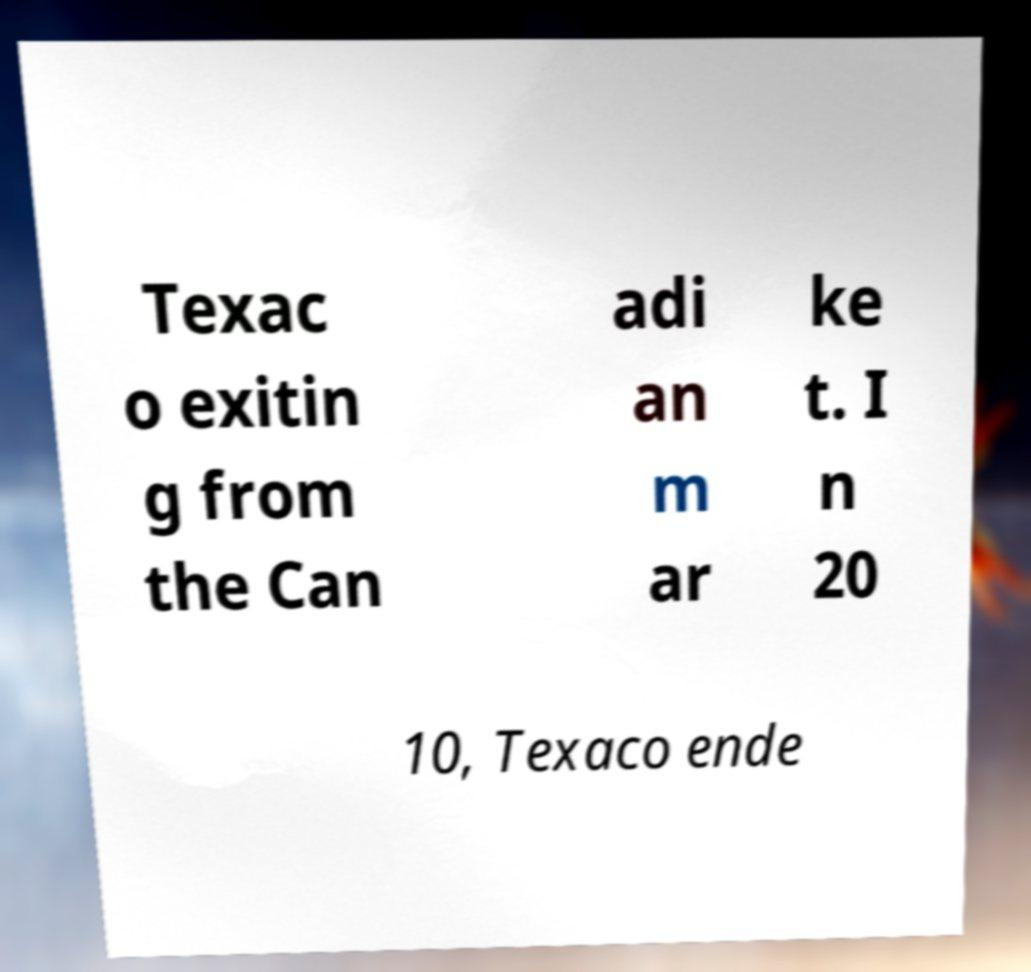Could you assist in decoding the text presented in this image and type it out clearly? Texac o exitin g from the Can adi an m ar ke t. I n 20 10, Texaco ende 